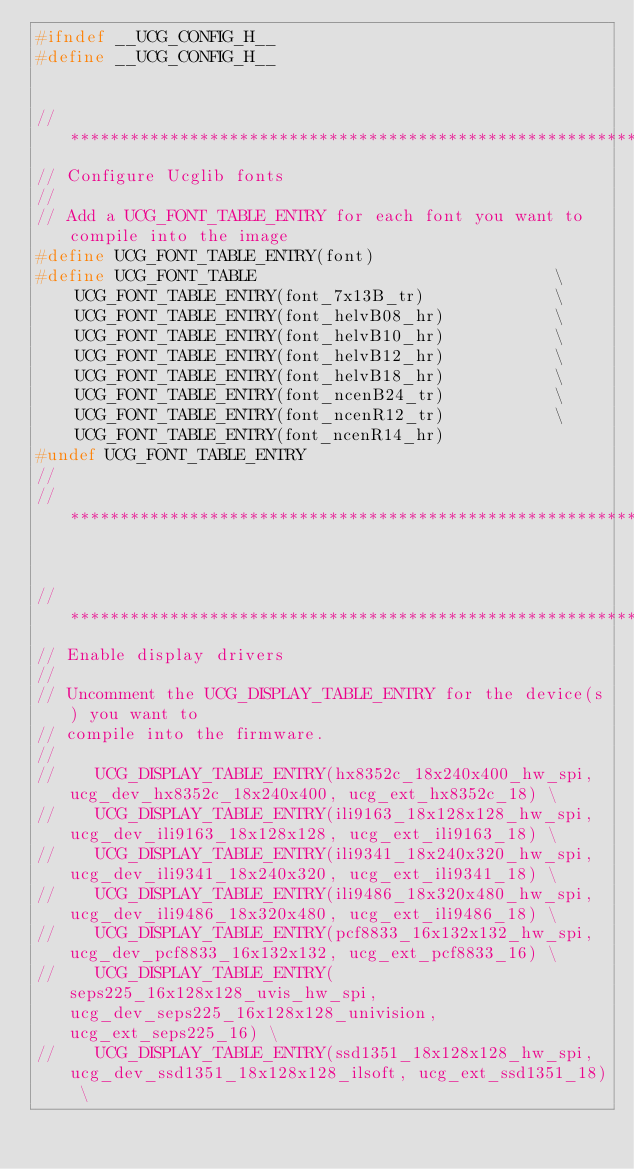Convert code to text. <code><loc_0><loc_0><loc_500><loc_500><_C_>#ifndef __UCG_CONFIG_H__
#define __UCG_CONFIG_H__


// ***************************************************************************
// Configure Ucglib fonts
//
// Add a UCG_FONT_TABLE_ENTRY for each font you want to compile into the image
#define UCG_FONT_TABLE_ENTRY(font)
#define UCG_FONT_TABLE                              \
    UCG_FONT_TABLE_ENTRY(font_7x13B_tr)             \
    UCG_FONT_TABLE_ENTRY(font_helvB08_hr)           \
    UCG_FONT_TABLE_ENTRY(font_helvB10_hr)           \
    UCG_FONT_TABLE_ENTRY(font_helvB12_hr)           \
    UCG_FONT_TABLE_ENTRY(font_helvB18_hr)           \
    UCG_FONT_TABLE_ENTRY(font_ncenB24_tr)           \
    UCG_FONT_TABLE_ENTRY(font_ncenR12_tr)           \
    UCG_FONT_TABLE_ENTRY(font_ncenR14_hr)
#undef UCG_FONT_TABLE_ENTRY
//
// ***************************************************************************


// ***************************************************************************
// Enable display drivers
//
// Uncomment the UCG_DISPLAY_TABLE_ENTRY for the device(s) you want to
// compile into the firmware.
//
//    UCG_DISPLAY_TABLE_ENTRY(hx8352c_18x240x400_hw_spi, ucg_dev_hx8352c_18x240x400, ucg_ext_hx8352c_18) \
//    UCG_DISPLAY_TABLE_ENTRY(ili9163_18x128x128_hw_spi, ucg_dev_ili9163_18x128x128, ucg_ext_ili9163_18) \
//    UCG_DISPLAY_TABLE_ENTRY(ili9341_18x240x320_hw_spi, ucg_dev_ili9341_18x240x320, ucg_ext_ili9341_18) \
//    UCG_DISPLAY_TABLE_ENTRY(ili9486_18x320x480_hw_spi, ucg_dev_ili9486_18x320x480, ucg_ext_ili9486_18) \
//    UCG_DISPLAY_TABLE_ENTRY(pcf8833_16x132x132_hw_spi, ucg_dev_pcf8833_16x132x132, ucg_ext_pcf8833_16) \
//    UCG_DISPLAY_TABLE_ENTRY(seps225_16x128x128_uvis_hw_spi, ucg_dev_seps225_16x128x128_univision, ucg_ext_seps225_16) \
//    UCG_DISPLAY_TABLE_ENTRY(ssd1351_18x128x128_hw_spi, ucg_dev_ssd1351_18x128x128_ilsoft, ucg_ext_ssd1351_18) \</code> 